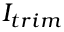Convert formula to latex. <formula><loc_0><loc_0><loc_500><loc_500>I _ { t r i m }</formula> 